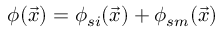Convert formula to latex. <formula><loc_0><loc_0><loc_500><loc_500>\phi ( \vec { x } ) = \phi _ { s i } ( \vec { x } ) + \phi _ { s m } ( \vec { x } )</formula> 